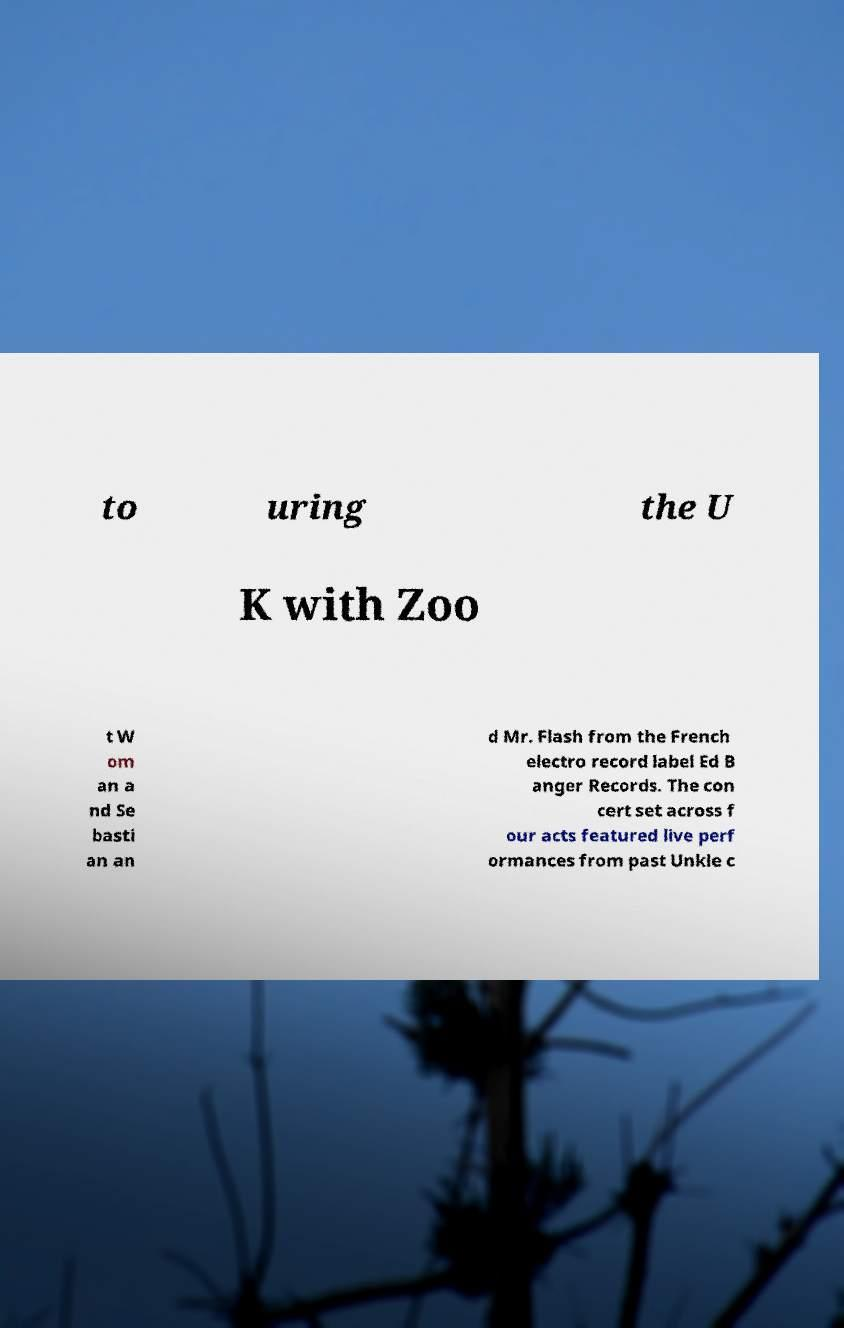Please read and relay the text visible in this image. What does it say? to uring the U K with Zoo t W om an a nd Se basti an an d Mr. Flash from the French electro record label Ed B anger Records. The con cert set across f our acts featured live perf ormances from past Unkle c 